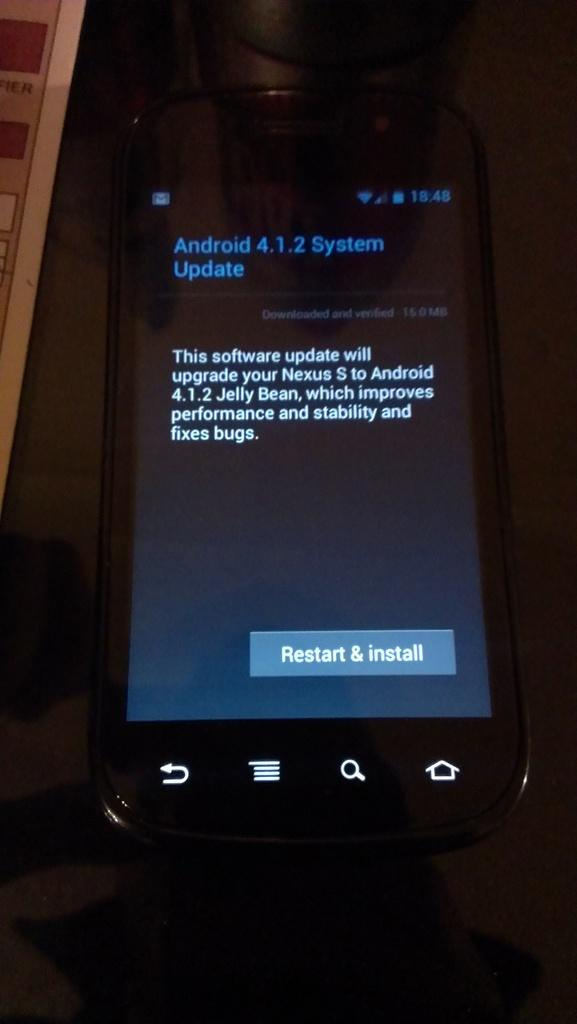<image>
Present a compact description of the photo's key features. an Android phone showing screen with 4.1.2 system Update 